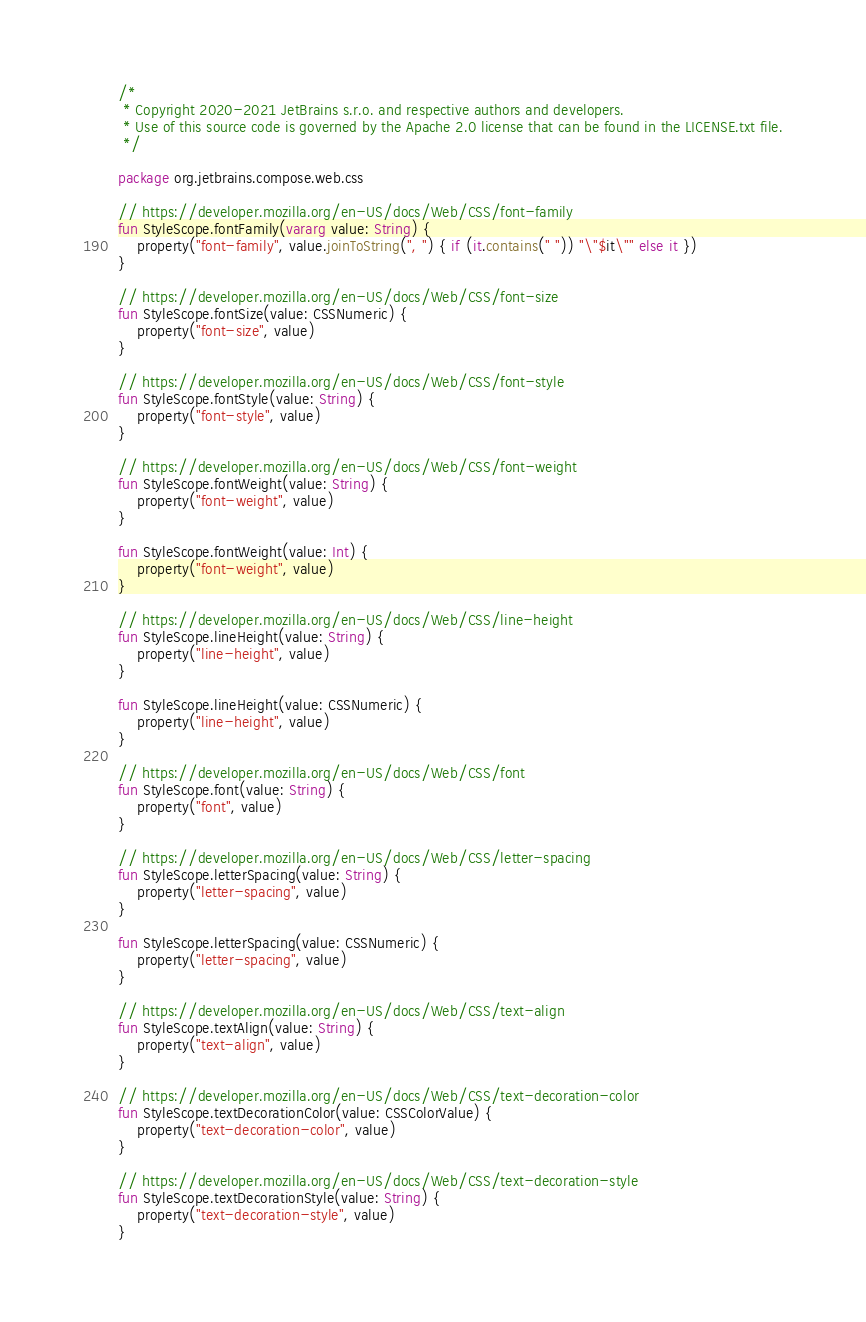Convert code to text. <code><loc_0><loc_0><loc_500><loc_500><_Kotlin_>/*
 * Copyright 2020-2021 JetBrains s.r.o. and respective authors and developers.
 * Use of this source code is governed by the Apache 2.0 license that can be found in the LICENSE.txt file.
 */

package org.jetbrains.compose.web.css

// https://developer.mozilla.org/en-US/docs/Web/CSS/font-family
fun StyleScope.fontFamily(vararg value: String) {
    property("font-family", value.joinToString(", ") { if (it.contains(" ")) "\"$it\"" else it })
}

// https://developer.mozilla.org/en-US/docs/Web/CSS/font-size
fun StyleScope.fontSize(value: CSSNumeric) {
    property("font-size", value)
}

// https://developer.mozilla.org/en-US/docs/Web/CSS/font-style
fun StyleScope.fontStyle(value: String) {
    property("font-style", value)
}

// https://developer.mozilla.org/en-US/docs/Web/CSS/font-weight
fun StyleScope.fontWeight(value: String) {
    property("font-weight", value)
}

fun StyleScope.fontWeight(value: Int) {
    property("font-weight", value)
}

// https://developer.mozilla.org/en-US/docs/Web/CSS/line-height
fun StyleScope.lineHeight(value: String) {
    property("line-height", value)
}

fun StyleScope.lineHeight(value: CSSNumeric) {
    property("line-height", value)
}

// https://developer.mozilla.org/en-US/docs/Web/CSS/font
fun StyleScope.font(value: String) {
    property("font", value)
}

// https://developer.mozilla.org/en-US/docs/Web/CSS/letter-spacing
fun StyleScope.letterSpacing(value: String) {
    property("letter-spacing", value)
}

fun StyleScope.letterSpacing(value: CSSNumeric) {
    property("letter-spacing", value)
}

// https://developer.mozilla.org/en-US/docs/Web/CSS/text-align
fun StyleScope.textAlign(value: String) {
    property("text-align", value)
}

// https://developer.mozilla.org/en-US/docs/Web/CSS/text-decoration-color
fun StyleScope.textDecorationColor(value: CSSColorValue) {
    property("text-decoration-color", value)
}

// https://developer.mozilla.org/en-US/docs/Web/CSS/text-decoration-style
fun StyleScope.textDecorationStyle(value: String) {
    property("text-decoration-style", value)
}
</code> 